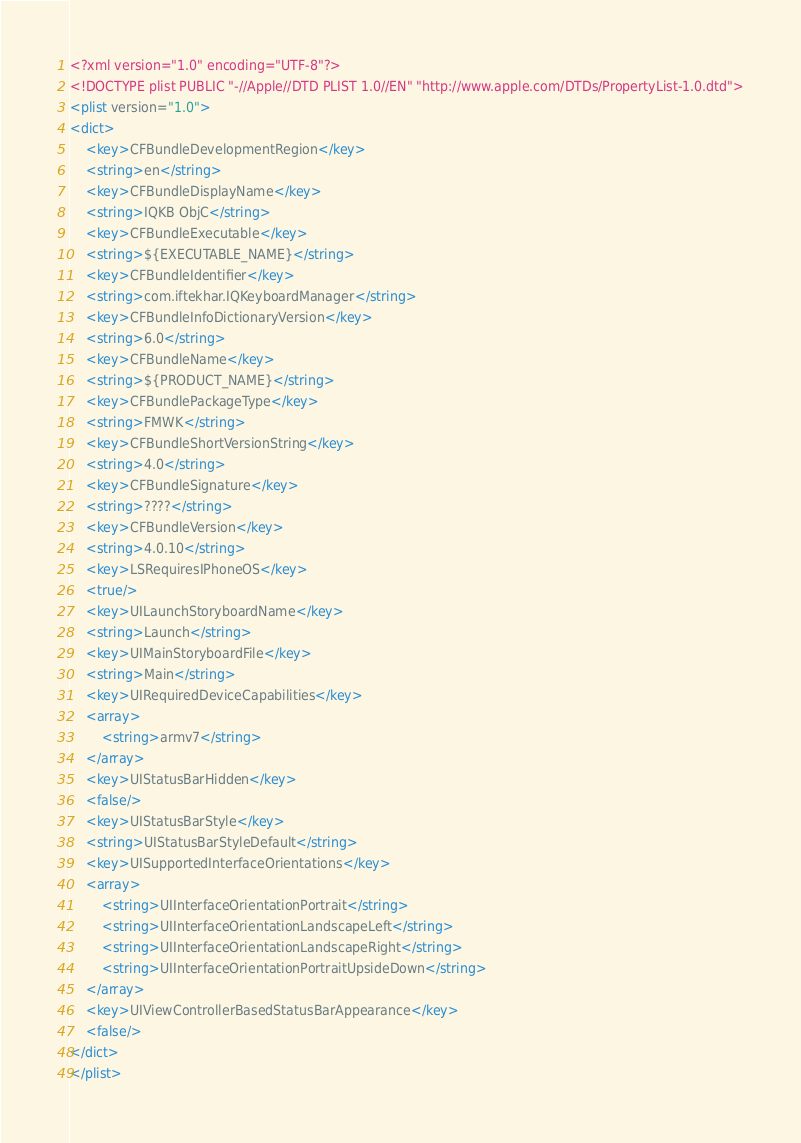Convert code to text. <code><loc_0><loc_0><loc_500><loc_500><_XML_><?xml version="1.0" encoding="UTF-8"?>
<!DOCTYPE plist PUBLIC "-//Apple//DTD PLIST 1.0//EN" "http://www.apple.com/DTDs/PropertyList-1.0.dtd">
<plist version="1.0">
<dict>
	<key>CFBundleDevelopmentRegion</key>
	<string>en</string>
	<key>CFBundleDisplayName</key>
	<string>IQKB ObjC</string>
	<key>CFBundleExecutable</key>
	<string>${EXECUTABLE_NAME}</string>
	<key>CFBundleIdentifier</key>
	<string>com.iftekhar.IQKeyboardManager</string>
	<key>CFBundleInfoDictionaryVersion</key>
	<string>6.0</string>
	<key>CFBundleName</key>
	<string>${PRODUCT_NAME}</string>
	<key>CFBundlePackageType</key>
	<string>FMWK</string>
	<key>CFBundleShortVersionString</key>
	<string>4.0</string>
	<key>CFBundleSignature</key>
	<string>????</string>
	<key>CFBundleVersion</key>
	<string>4.0.10</string>
	<key>LSRequiresIPhoneOS</key>
	<true/>
	<key>UILaunchStoryboardName</key>
	<string>Launch</string>
	<key>UIMainStoryboardFile</key>
	<string>Main</string>
	<key>UIRequiredDeviceCapabilities</key>
	<array>
		<string>armv7</string>
	</array>
	<key>UIStatusBarHidden</key>
	<false/>
	<key>UIStatusBarStyle</key>
	<string>UIStatusBarStyleDefault</string>
	<key>UISupportedInterfaceOrientations</key>
	<array>
		<string>UIInterfaceOrientationPortrait</string>
		<string>UIInterfaceOrientationLandscapeLeft</string>
		<string>UIInterfaceOrientationLandscapeRight</string>
		<string>UIInterfaceOrientationPortraitUpsideDown</string>
	</array>
	<key>UIViewControllerBasedStatusBarAppearance</key>
	<false/>
</dict>
</plist>
</code> 